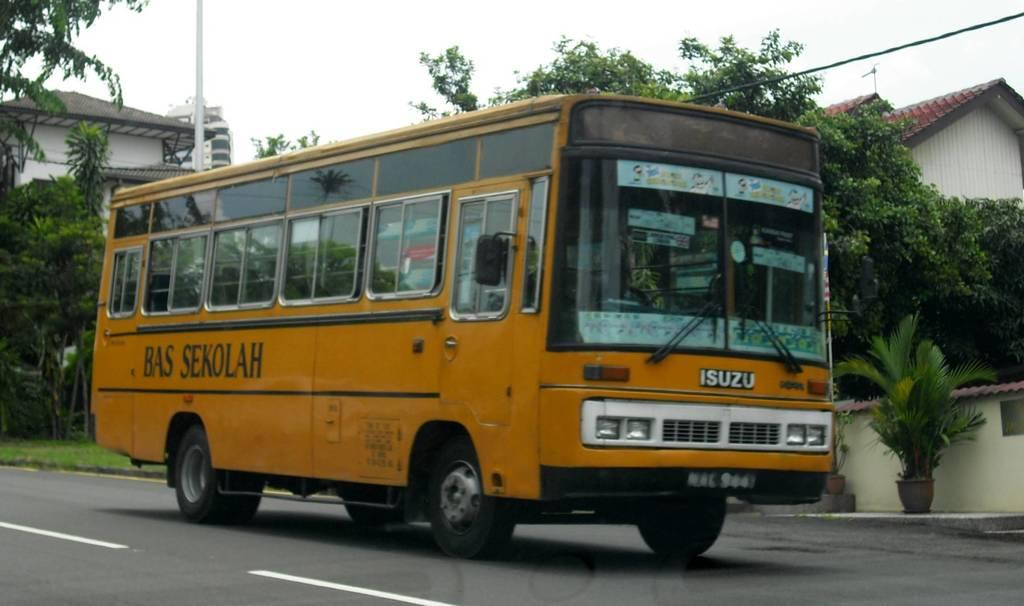What is the main subject of the image? There is a vehicle in the image. Where is the vehicle located? The vehicle is on the road. What other elements can be seen in the image? There are plants, trees, buildings, a pole, and the sky visible in the image. What type of mint is being used to flavor the vehicle in the image? There is no mint present in the image, and the vehicle is not being flavored. 